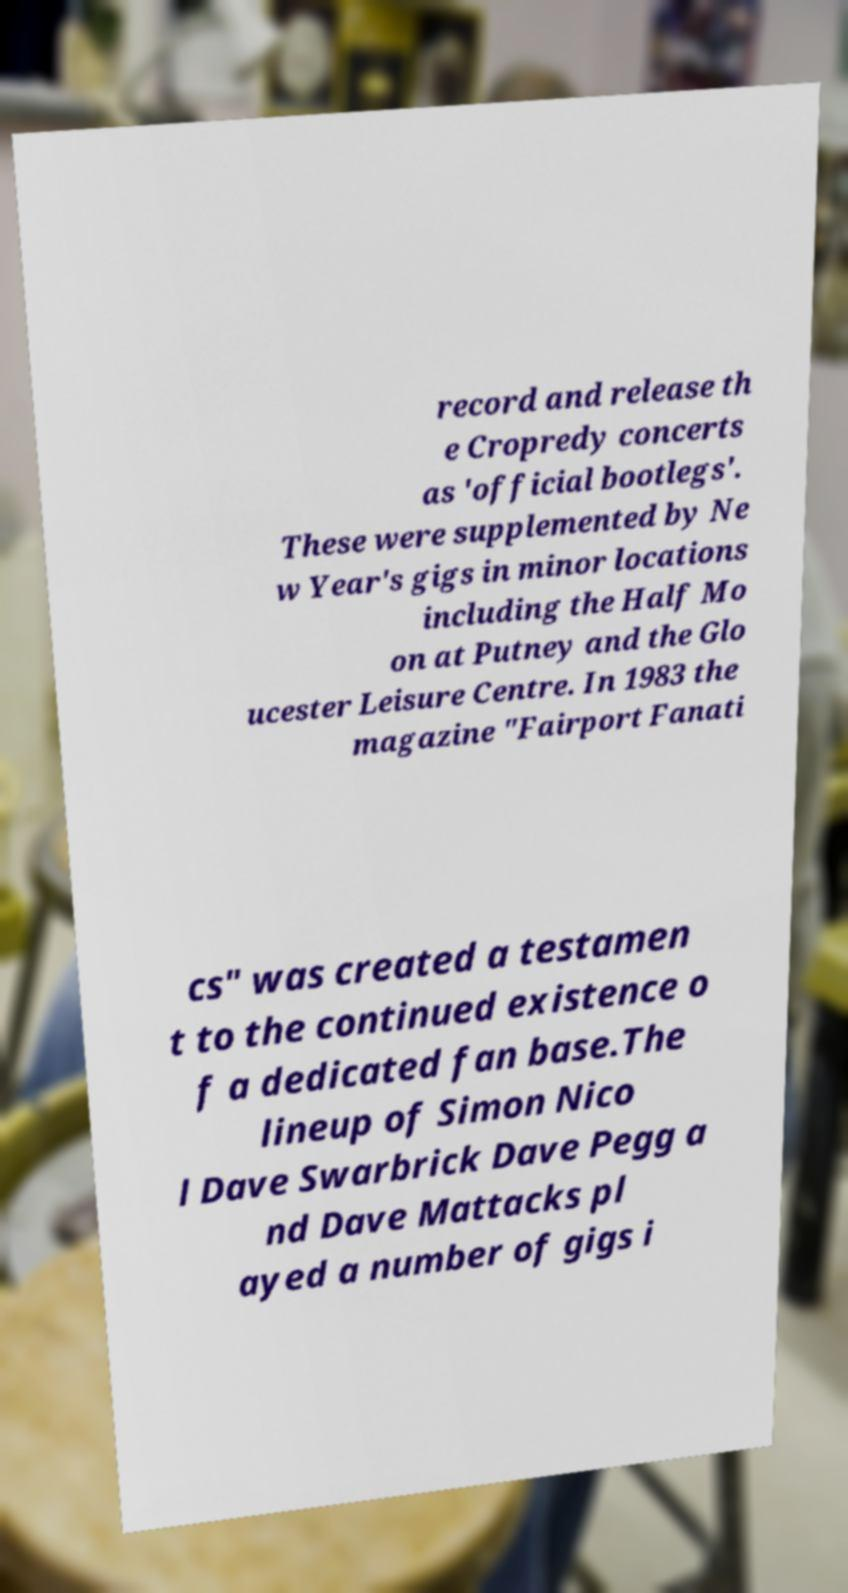Could you assist in decoding the text presented in this image and type it out clearly? record and release th e Cropredy concerts as 'official bootlegs'. These were supplemented by Ne w Year's gigs in minor locations including the Half Mo on at Putney and the Glo ucester Leisure Centre. In 1983 the magazine "Fairport Fanati cs" was created a testamen t to the continued existence o f a dedicated fan base.The lineup of Simon Nico l Dave Swarbrick Dave Pegg a nd Dave Mattacks pl ayed a number of gigs i 